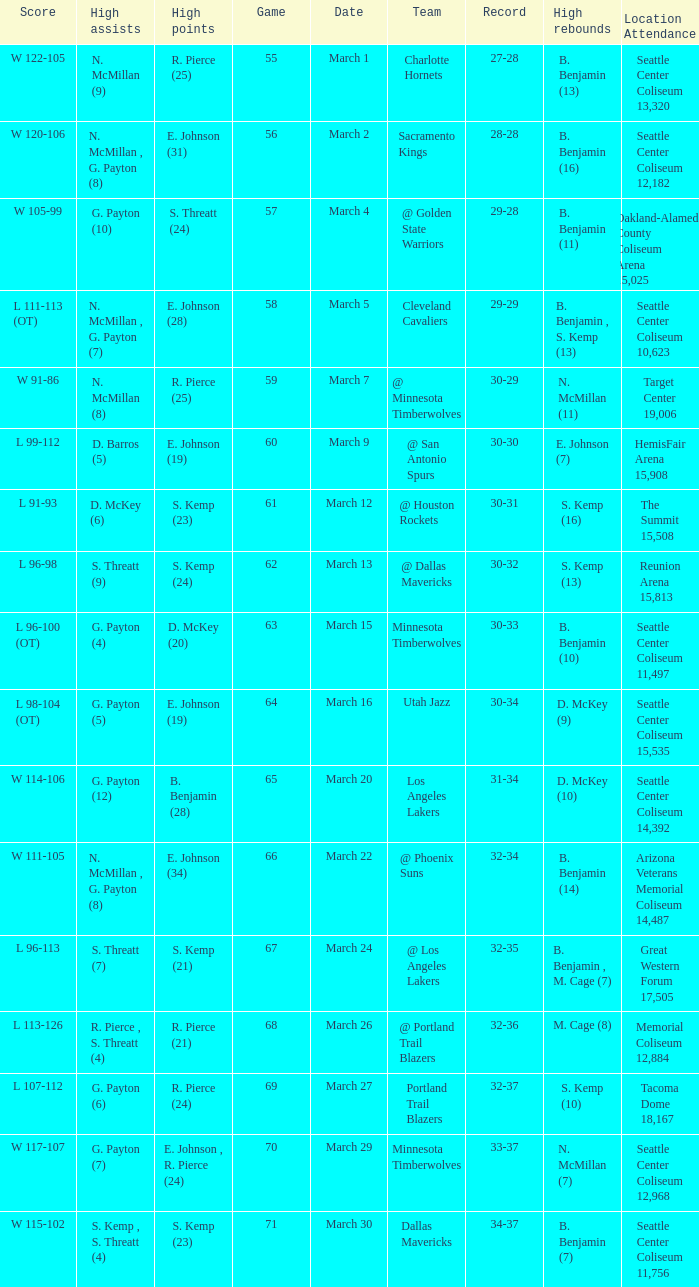Which Game has a Team of portland trail blazers? 69.0. 